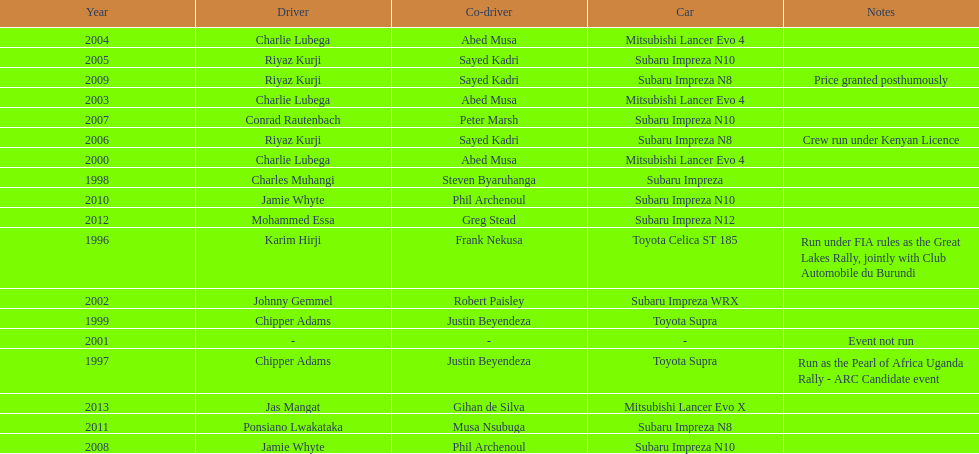How many drivers won at least twice? 4. 